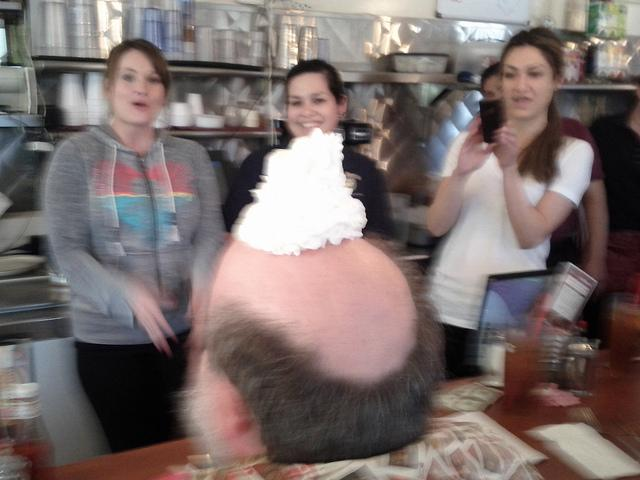What does the woman do with her phone?

Choices:
A) take photo
B) call
C) text
D) auto dial take photo 